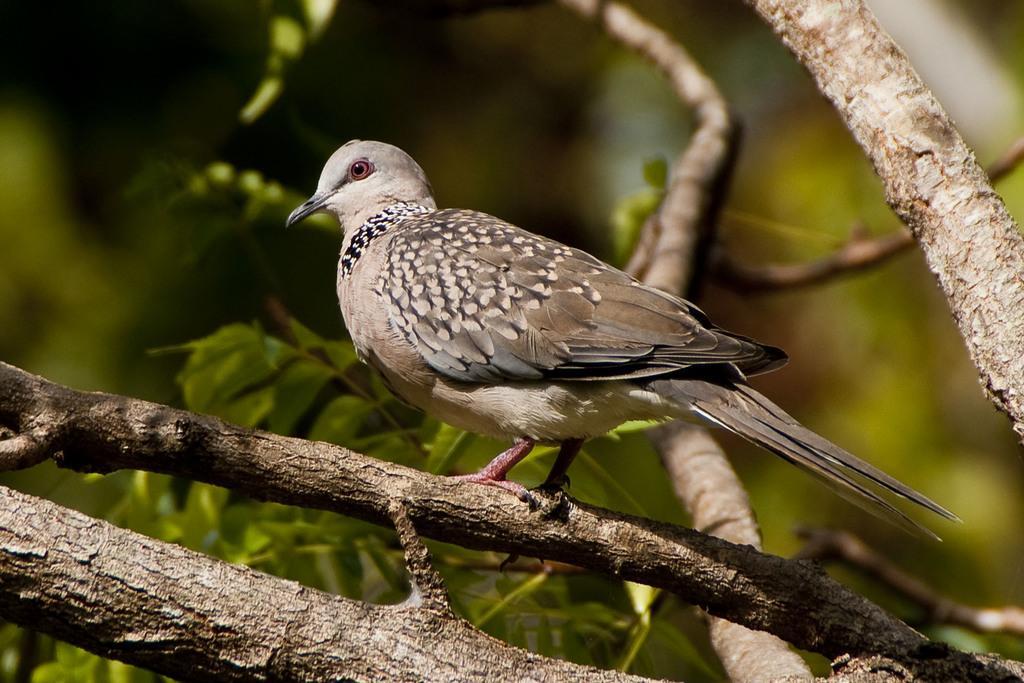Could you give a brief overview of what you see in this image? This image is taken outdoors. In this image the background is a little blurred and it is green in color. In the middle of the image there is a tree with leaves, stems and branches. There is a bird on the branch of a tree. 